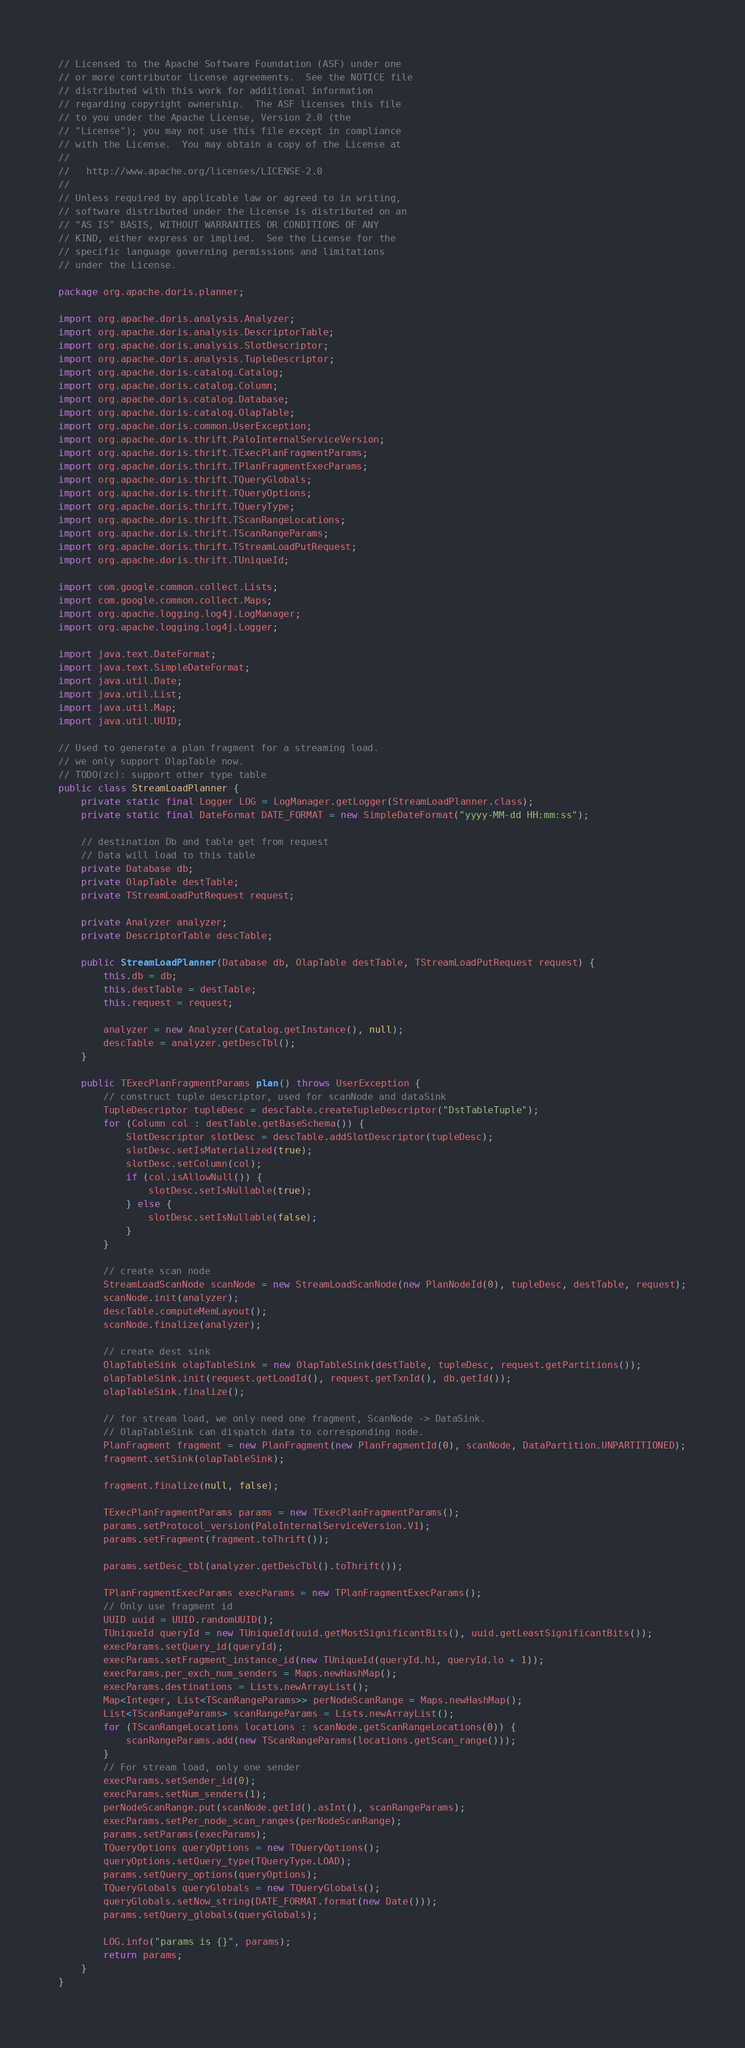Convert code to text. <code><loc_0><loc_0><loc_500><loc_500><_Java_>// Licensed to the Apache Software Foundation (ASF) under one
// or more contributor license agreements.  See the NOTICE file
// distributed with this work for additional information
// regarding copyright ownership.  The ASF licenses this file
// to you under the Apache License, Version 2.0 (the
// "License"); you may not use this file except in compliance
// with the License.  You may obtain a copy of the License at
//
//   http://www.apache.org/licenses/LICENSE-2.0
//
// Unless required by applicable law or agreed to in writing,
// software distributed under the License is distributed on an
// "AS IS" BASIS, WITHOUT WARRANTIES OR CONDITIONS OF ANY
// KIND, either express or implied.  See the License for the
// specific language governing permissions and limitations
// under the License.

package org.apache.doris.planner;

import org.apache.doris.analysis.Analyzer;
import org.apache.doris.analysis.DescriptorTable;
import org.apache.doris.analysis.SlotDescriptor;
import org.apache.doris.analysis.TupleDescriptor;
import org.apache.doris.catalog.Catalog;
import org.apache.doris.catalog.Column;
import org.apache.doris.catalog.Database;
import org.apache.doris.catalog.OlapTable;
import org.apache.doris.common.UserException;
import org.apache.doris.thrift.PaloInternalServiceVersion;
import org.apache.doris.thrift.TExecPlanFragmentParams;
import org.apache.doris.thrift.TPlanFragmentExecParams;
import org.apache.doris.thrift.TQueryGlobals;
import org.apache.doris.thrift.TQueryOptions;
import org.apache.doris.thrift.TQueryType;
import org.apache.doris.thrift.TScanRangeLocations;
import org.apache.doris.thrift.TScanRangeParams;
import org.apache.doris.thrift.TStreamLoadPutRequest;
import org.apache.doris.thrift.TUniqueId;

import com.google.common.collect.Lists;
import com.google.common.collect.Maps;
import org.apache.logging.log4j.LogManager;
import org.apache.logging.log4j.Logger;

import java.text.DateFormat;
import java.text.SimpleDateFormat;
import java.util.Date;
import java.util.List;
import java.util.Map;
import java.util.UUID;

// Used to generate a plan fragment for a streaming load.
// we only support OlapTable now.
// TODO(zc): support other type table
public class StreamLoadPlanner {
    private static final Logger LOG = LogManager.getLogger(StreamLoadPlanner.class);
    private static final DateFormat DATE_FORMAT = new SimpleDateFormat("yyyy-MM-dd HH:mm:ss");

    // destination Db and table get from request
    // Data will load to this table
    private Database db;
    private OlapTable destTable;
    private TStreamLoadPutRequest request;

    private Analyzer analyzer;
    private DescriptorTable descTable;

    public StreamLoadPlanner(Database db, OlapTable destTable, TStreamLoadPutRequest request) {
        this.db = db;
        this.destTable = destTable;
        this.request = request;

        analyzer = new Analyzer(Catalog.getInstance(), null);
        descTable = analyzer.getDescTbl();
    }

    public TExecPlanFragmentParams plan() throws UserException {
        // construct tuple descriptor, used for scanNode and dataSink
        TupleDescriptor tupleDesc = descTable.createTupleDescriptor("DstTableTuple");
        for (Column col : destTable.getBaseSchema()) {
            SlotDescriptor slotDesc = descTable.addSlotDescriptor(tupleDesc);
            slotDesc.setIsMaterialized(true);
            slotDesc.setColumn(col);
            if (col.isAllowNull()) {
                slotDesc.setIsNullable(true);
            } else {
                slotDesc.setIsNullable(false);
            }
        }

        // create scan node
        StreamLoadScanNode scanNode = new StreamLoadScanNode(new PlanNodeId(0), tupleDesc, destTable, request);
        scanNode.init(analyzer);
        descTable.computeMemLayout();
        scanNode.finalize(analyzer);

        // create dest sink
        OlapTableSink olapTableSink = new OlapTableSink(destTable, tupleDesc, request.getPartitions());
        olapTableSink.init(request.getLoadId(), request.getTxnId(), db.getId());
        olapTableSink.finalize();

        // for stream load, we only need one fragment, ScanNode -> DataSink.
        // OlapTableSink can dispatch data to corresponding node.
        PlanFragment fragment = new PlanFragment(new PlanFragmentId(0), scanNode, DataPartition.UNPARTITIONED);
        fragment.setSink(olapTableSink);

        fragment.finalize(null, false);

        TExecPlanFragmentParams params = new TExecPlanFragmentParams();
        params.setProtocol_version(PaloInternalServiceVersion.V1);
        params.setFragment(fragment.toThrift());

        params.setDesc_tbl(analyzer.getDescTbl().toThrift());

        TPlanFragmentExecParams execParams = new TPlanFragmentExecParams();
        // Only use fragment id
        UUID uuid = UUID.randomUUID();
        TUniqueId queryId = new TUniqueId(uuid.getMostSignificantBits(), uuid.getLeastSignificantBits());
        execParams.setQuery_id(queryId);
        execParams.setFragment_instance_id(new TUniqueId(queryId.hi, queryId.lo + 1));
        execParams.per_exch_num_senders = Maps.newHashMap();
        execParams.destinations = Lists.newArrayList();
        Map<Integer, List<TScanRangeParams>> perNodeScanRange = Maps.newHashMap();
        List<TScanRangeParams> scanRangeParams = Lists.newArrayList();
        for (TScanRangeLocations locations : scanNode.getScanRangeLocations(0)) {
            scanRangeParams.add(new TScanRangeParams(locations.getScan_range()));
        }
        // For stream load, only one sender
        execParams.setSender_id(0);
        execParams.setNum_senders(1);
        perNodeScanRange.put(scanNode.getId().asInt(), scanRangeParams);
        execParams.setPer_node_scan_ranges(perNodeScanRange);
        params.setParams(execParams);
        TQueryOptions queryOptions = new TQueryOptions();
        queryOptions.setQuery_type(TQueryType.LOAD);
        params.setQuery_options(queryOptions);
        TQueryGlobals queryGlobals = new TQueryGlobals();
        queryGlobals.setNow_string(DATE_FORMAT.format(new Date()));
        params.setQuery_globals(queryGlobals);

        LOG.info("params is {}", params);
        return params;
    }
}
</code> 